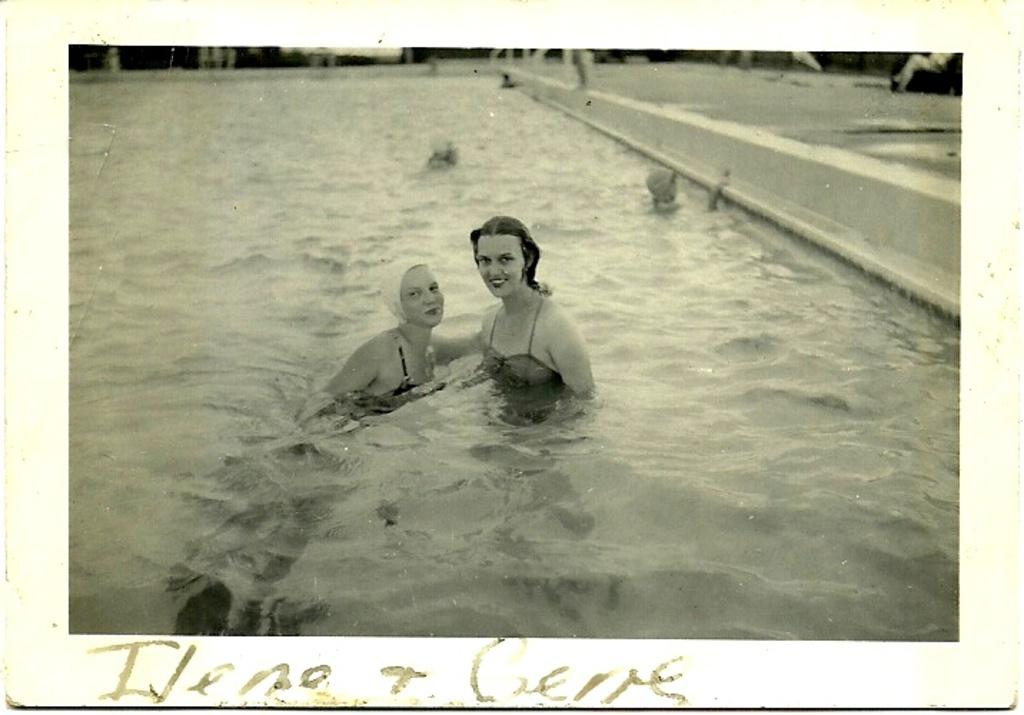What is the color scheme of the image? The image is black and white. How many people are in the image? There are two women in the image. What are the women doing in the image? The women are in water. What is the facial expression of the women in the image? The women are smiling. What type of card game are the women playing in the image? There is no card game present in the image; the women are in water and smiling. 